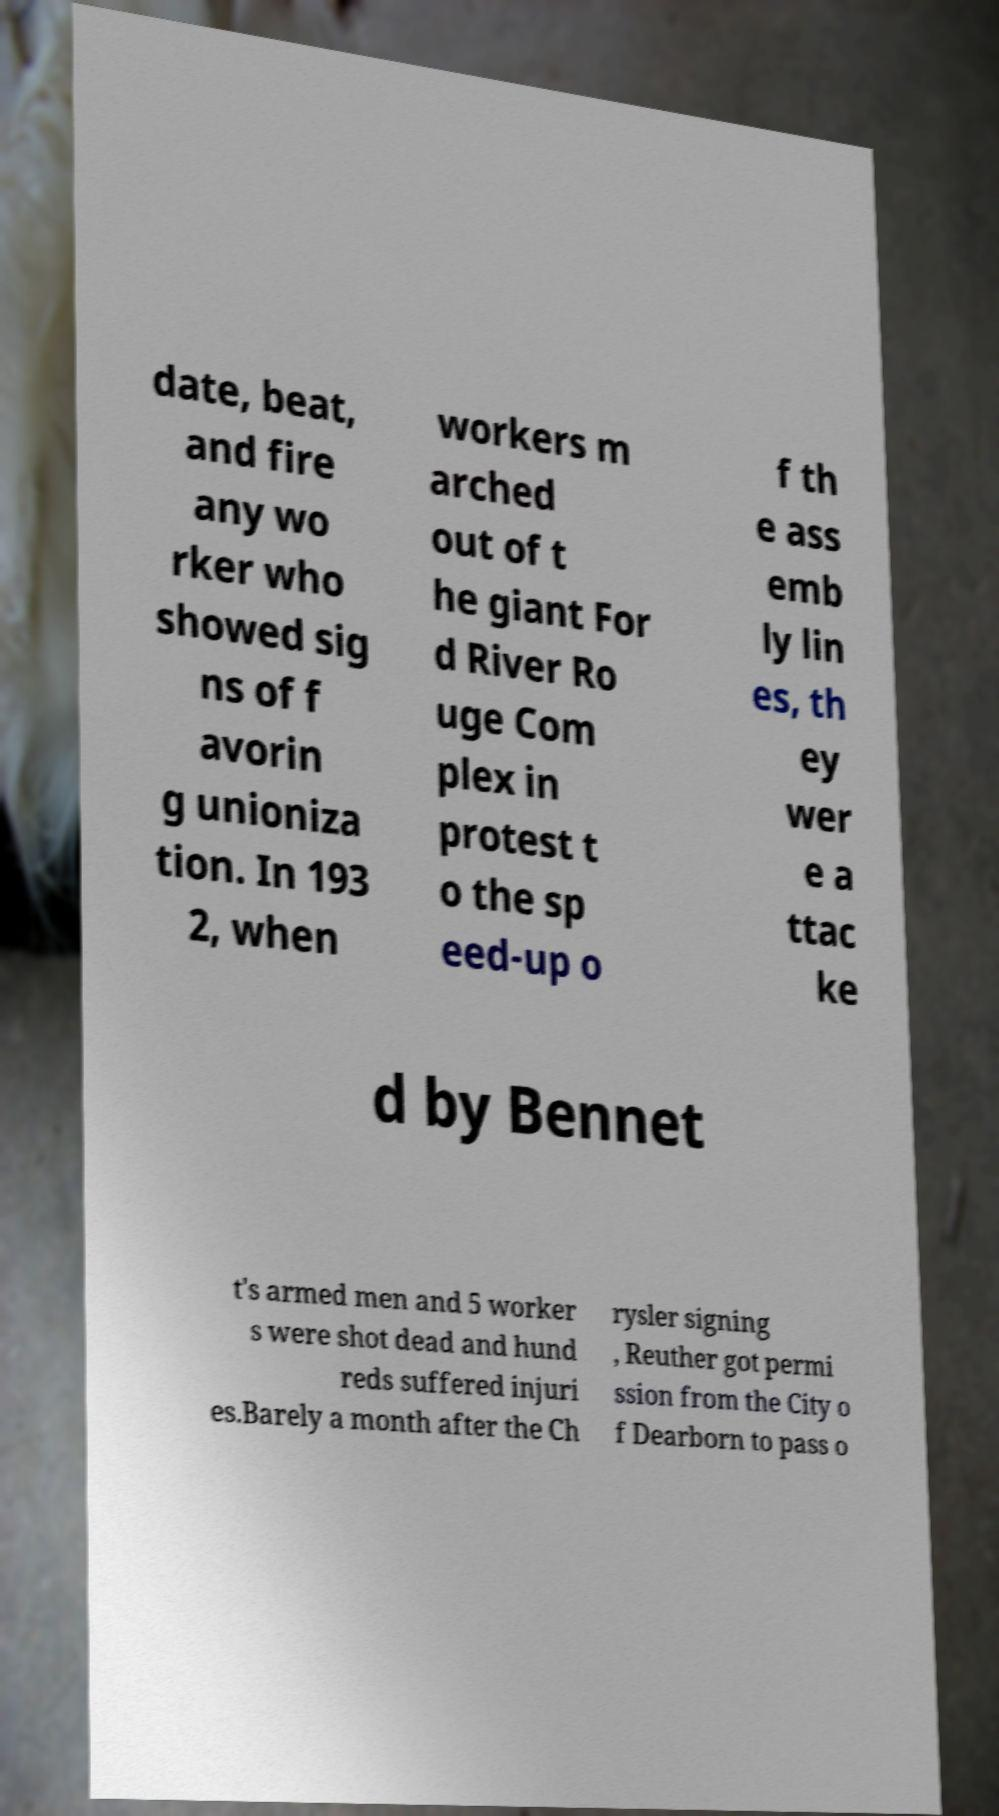There's text embedded in this image that I need extracted. Can you transcribe it verbatim? date, beat, and fire any wo rker who showed sig ns of f avorin g unioniza tion. In 193 2, when workers m arched out of t he giant For d River Ro uge Com plex in protest t o the sp eed-up o f th e ass emb ly lin es, th ey wer e a ttac ke d by Bennet t's armed men and 5 worker s were shot dead and hund reds suffered injuri es.Barely a month after the Ch rysler signing , Reuther got permi ssion from the City o f Dearborn to pass o 